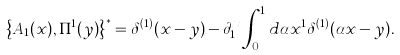Convert formula to latex. <formula><loc_0><loc_0><loc_500><loc_500>\left \{ { A _ { 1 } ( x ) , \Pi ^ { 1 } ( y ) } \right \} ^ { * } = \delta ^ { ( 1 ) } ( x - y ) - \partial _ { 1 } ^ { x } \int _ { 0 } ^ { 1 } { d \alpha x ^ { 1 } \delta ^ { ( 1 ) } } ( \alpha x - y ) .</formula> 